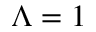<formula> <loc_0><loc_0><loc_500><loc_500>\Lambda = 1</formula> 